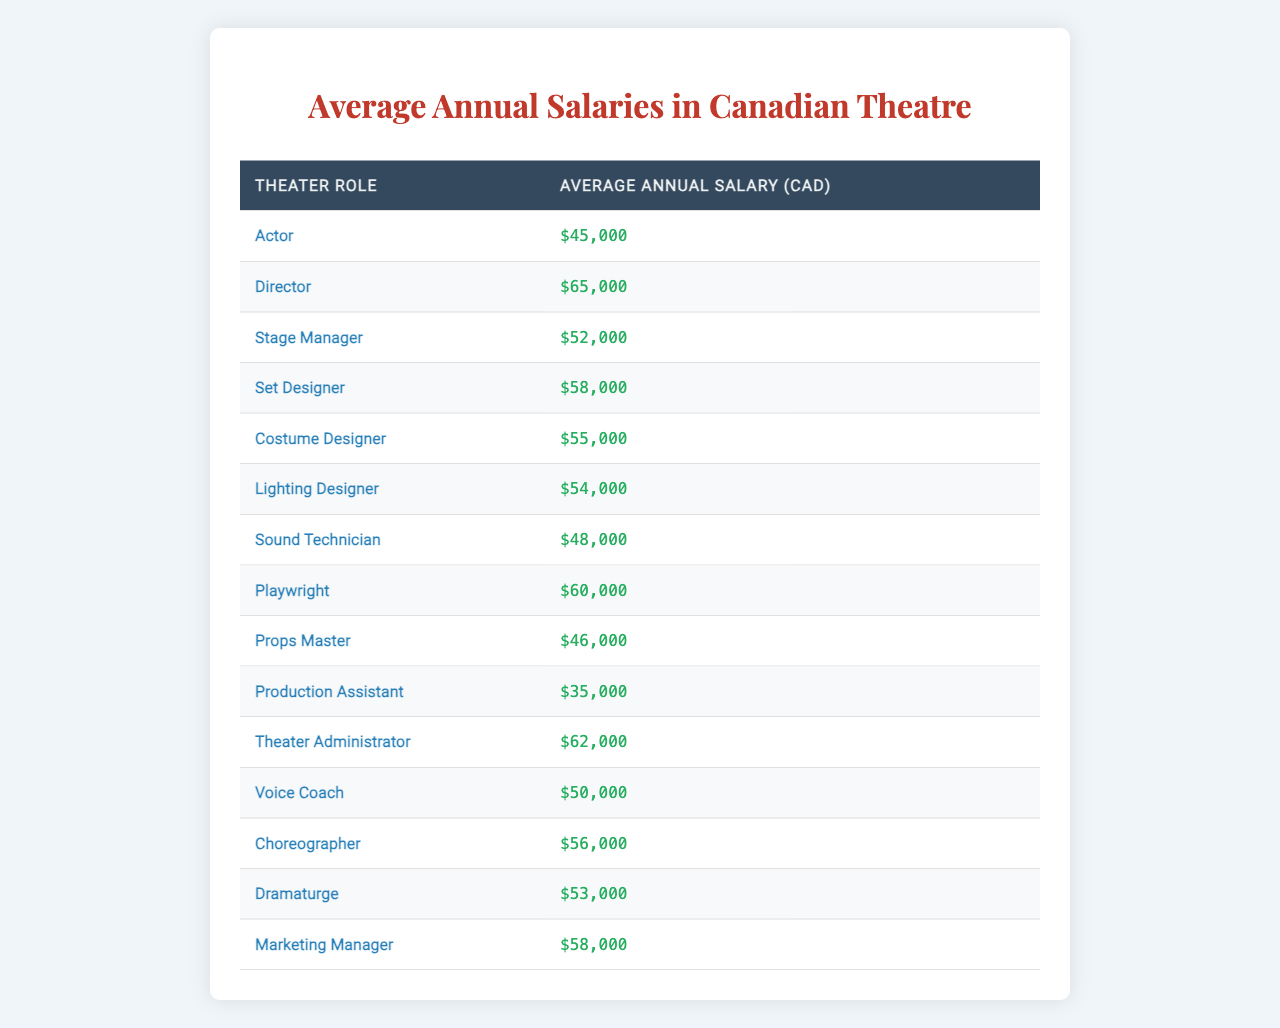What is the average salary of an Actor in Canada? The table lists the average salary of an Actor as $45,000.
Answer: $45,000 Which role has the highest average salary? Reviewing the table, the Director has the highest salary at $65,000.
Answer: Director What is the average salary of a Stage Manager compared to a Sound Technician? The average salary of a Stage Manager is $52,000, while a Sound Technician earns $48,000. Therefore, the Stage Manager earns $4,000 more than the Sound Technician.
Answer: $4,000 Is the average salary of a Costume Designer higher than that of a Props Master? The table shows the average salary of a Costume Designer ($55,000) is greater than that of a Props Master ($46,000). Therefore, this statement is true.
Answer: Yes What is the total of the average salaries of the roles from Actor up to Lighting Designer? Summing the salaries: $45,000 + $65,000 + $52,000 + $58,000 + $55,000 + $54,000 gives a total of $329,000.
Answer: $329,000 Which design role has the highest salary, Set Designer or Costume Designer? The salary of a Set Designer is $58,000, while a Costume Designer earns $55,000, making the Set Designer the higher-paid role.
Answer: Set Designer If you combine the salaries of a Playwright and a Theater Administrator, what is the total? The average salary of a Playwright is $60,000 and a Theater Administrator is $62,000. Their total is $60,000 + $62,000 = $122,000.
Answer: $122,000 What is the average salary of a Director and a Choreographer? The Director earns $65,000 and the Choreographer earns $56,000. The average of these two amounts is ($65,000 + $56,000)/2 = $60,500.
Answer: $60,500 Is the average salary of a Voice Coach equal to or greater than that of a Sound Technician? The average salary for a Voice Coach is $50,000, while a Sound Technician earns $48,000. Thus, the Voice Coach's salary is greater.
Answer: Yes Calculate the difference in average salary between a Lighting Designer and a Stage Manager. The Lighting Designer earns $54,000, whereas the Stage Manager earns $52,000. The difference is $54,000 - $52,000 = $2,000.
Answer: $2,000 